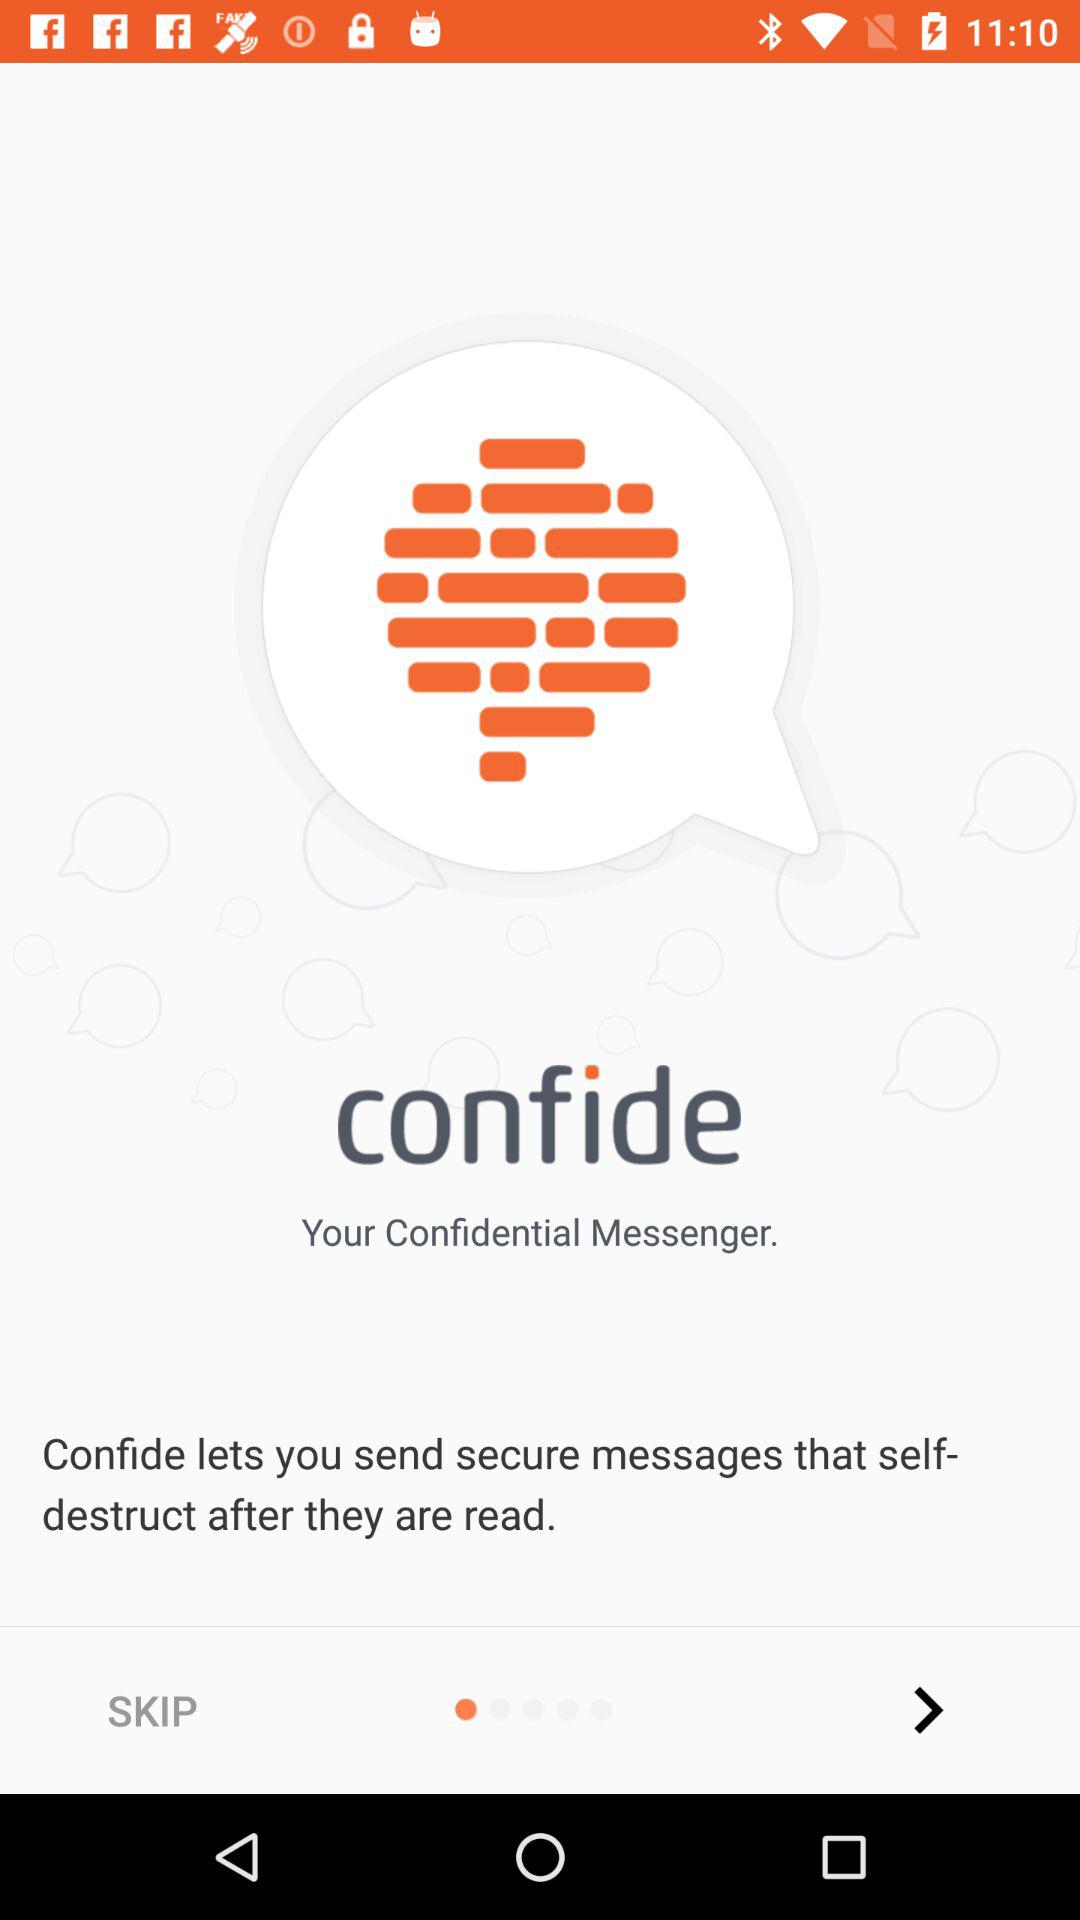What is the app name? The app name is "confide". 